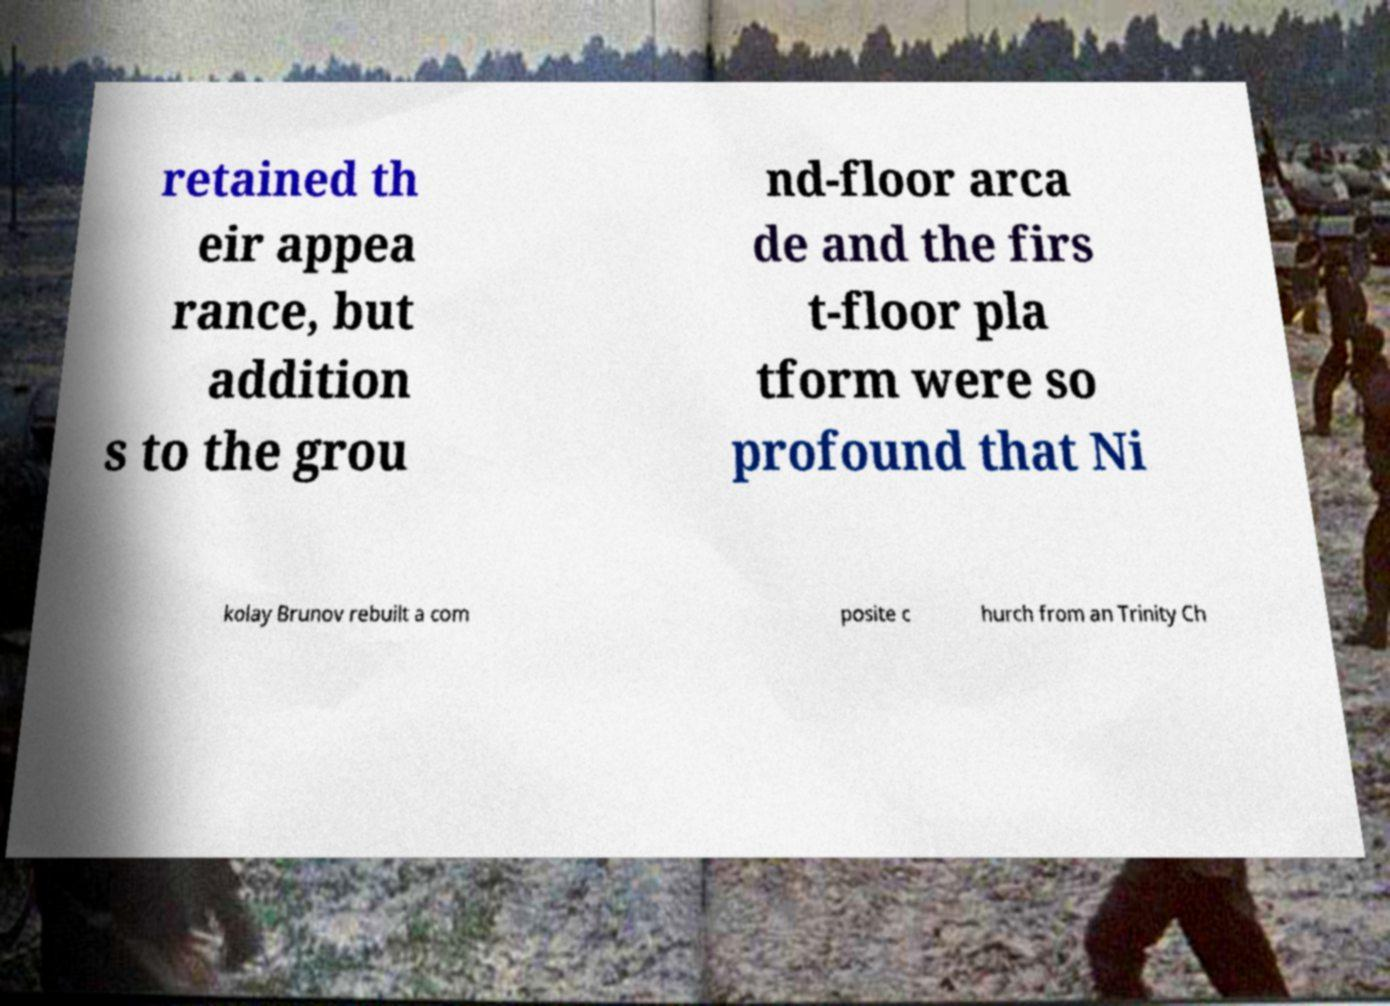Could you assist in decoding the text presented in this image and type it out clearly? retained th eir appea rance, but addition s to the grou nd-floor arca de and the firs t-floor pla tform were so profound that Ni kolay Brunov rebuilt a com posite c hurch from an Trinity Ch 